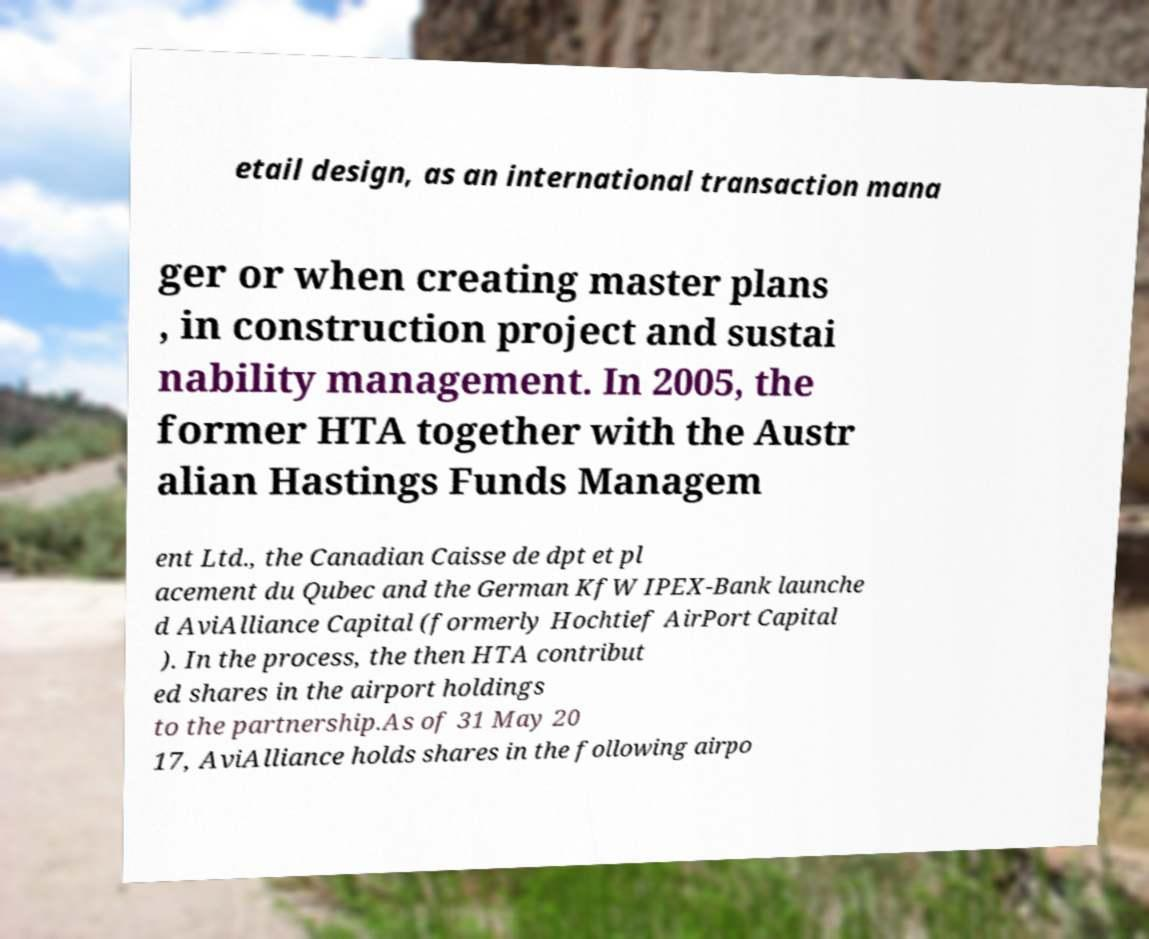Can you read and provide the text displayed in the image?This photo seems to have some interesting text. Can you extract and type it out for me? etail design, as an international transaction mana ger or when creating master plans , in construction project and sustai nability management. In 2005, the former HTA together with the Austr alian Hastings Funds Managem ent Ltd., the Canadian Caisse de dpt et pl acement du Qubec and the German KfW IPEX-Bank launche d AviAlliance Capital (formerly Hochtief AirPort Capital ). In the process, the then HTA contribut ed shares in the airport holdings to the partnership.As of 31 May 20 17, AviAlliance holds shares in the following airpo 